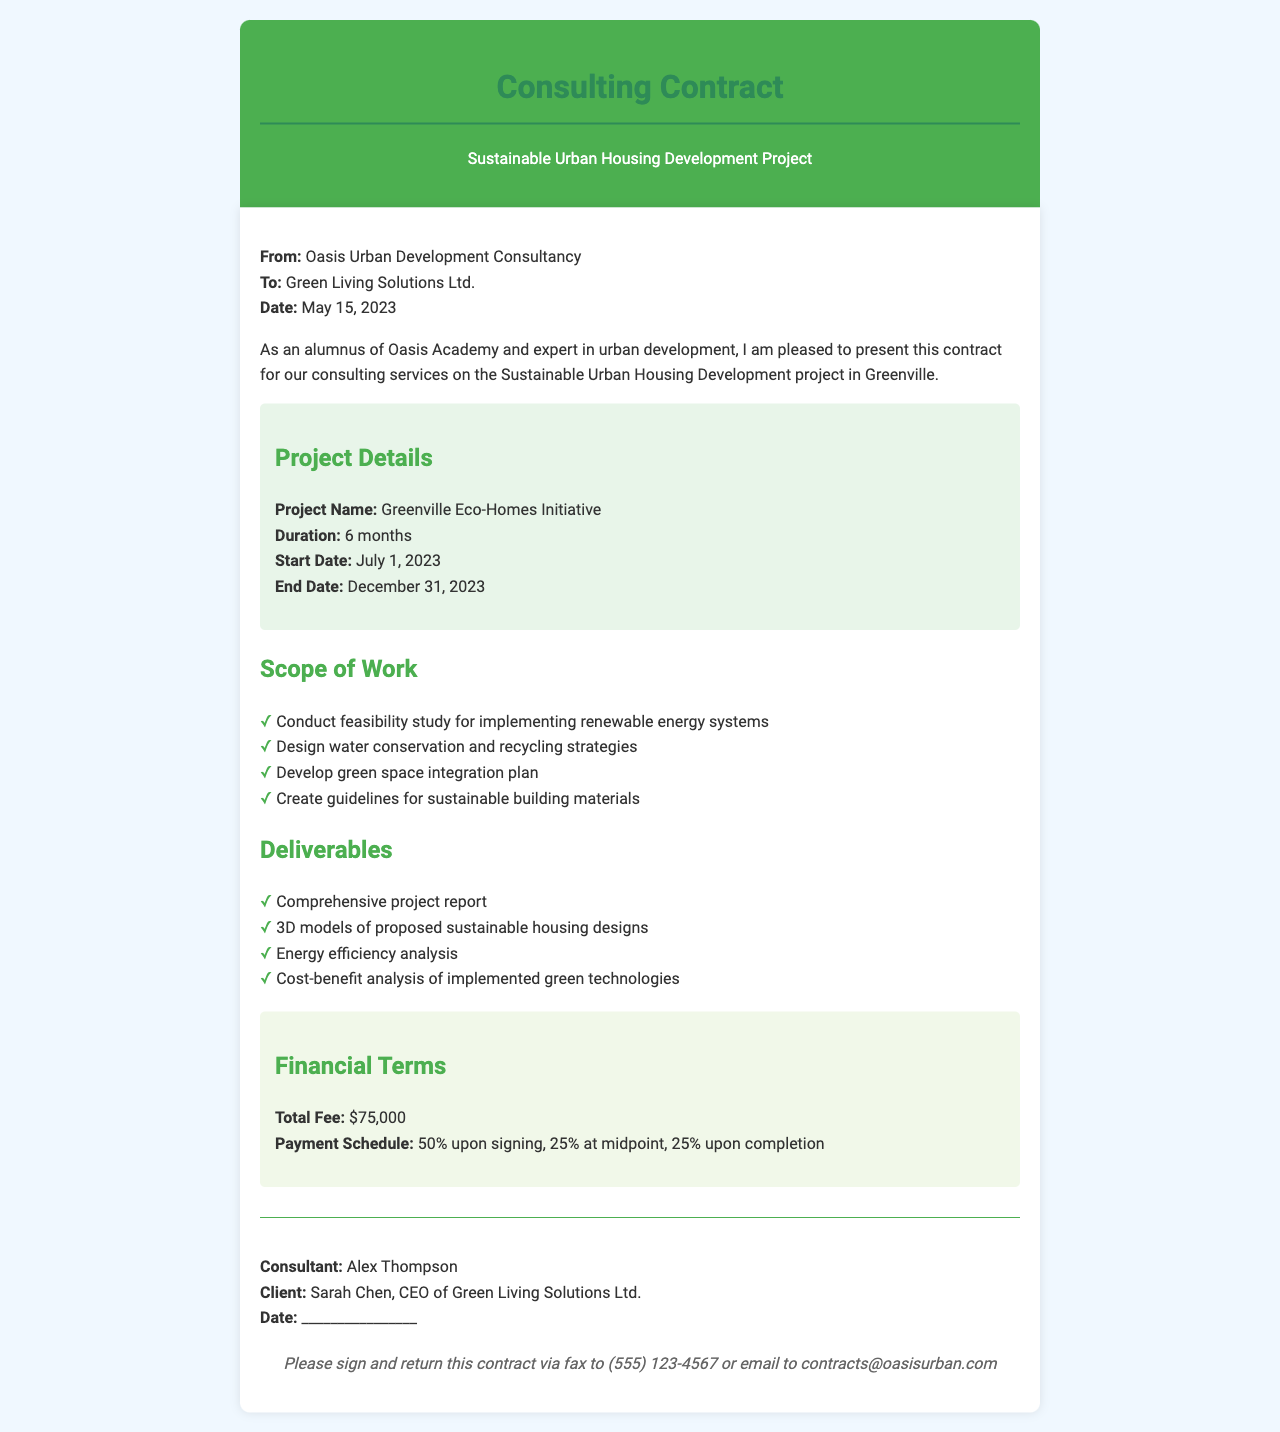what is the project name? The project name is explicitly mentioned in the project details section of the document.
Answer: Greenville Eco-Homes Initiative what is the total fee for the project? The total fee is stated under the financial terms section of the document.
Answer: $75,000 who is the consultant's name? The consultant's name is provided in the signature block at the end of the document.
Answer: Alex Thompson when does the project start? The start date is listed in the project details section of the document.
Answer: July 1, 2023 how long is the project duration? The duration of the project is mentioned in the project details section.
Answer: 6 months what percentage of the fee is due upon signing? The payment schedule explicitly states the percentage due upon signing.
Answer: 50% which company is the client? The client's name is indicated at the top of the document.
Answer: Green Living Solutions Ltd what should be done with the signed contract? The instructions in the footer state the preferred method of returning the signed contract.
Answer: Fax or email how many deliverables are listed in the document? The number of deliverables can be counted from the list under the deliverables section.
Answer: 4 